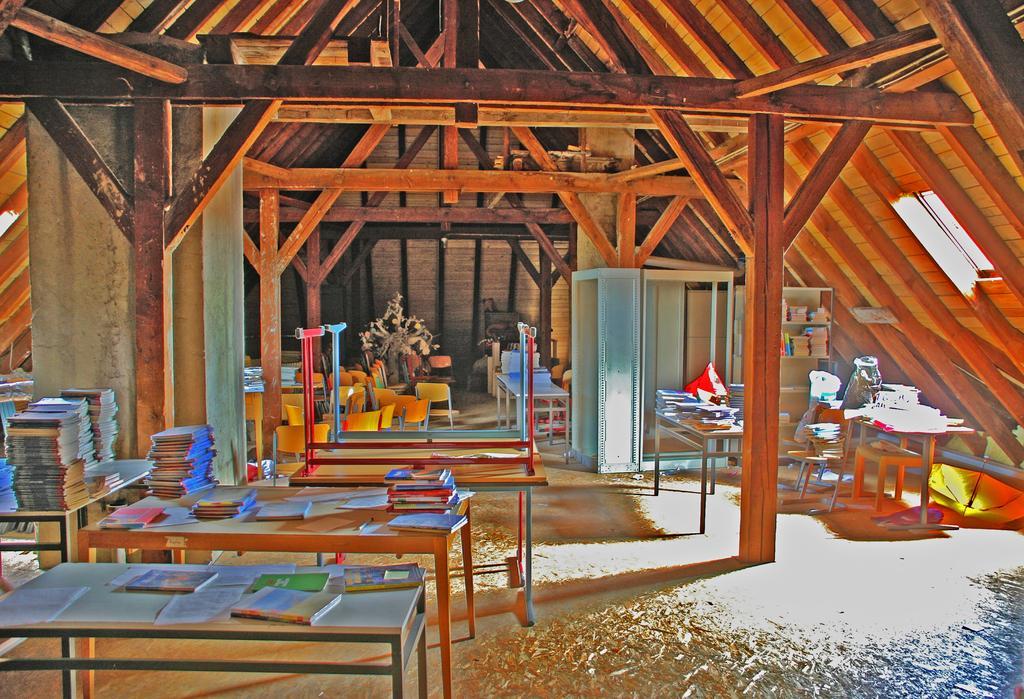How would you summarize this image in a sentence or two? This is an edited image. In the foreground left there are tables, on the tables there are books. This is a wooden house. In the background there are many chairs. On the top right there are tables chairs, books and racks. On the right there is a window. Floor is covered with dust. 